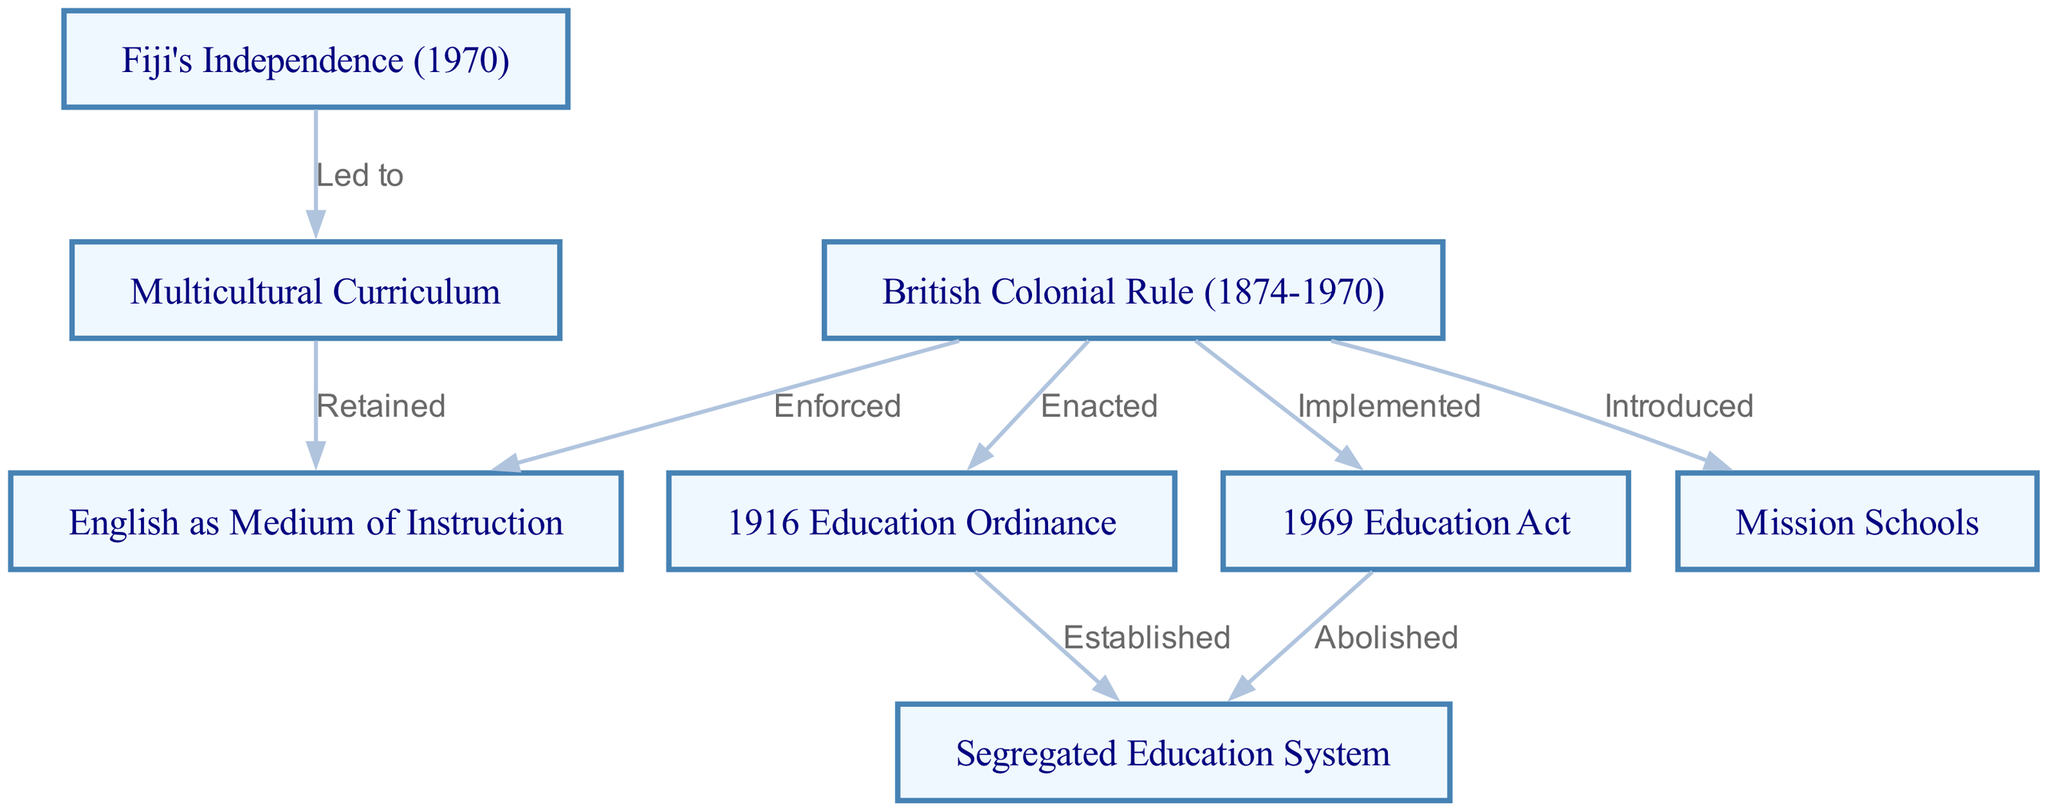What is the starting point of the directed graph? The directed graph starts from the node labeled "British Colonial Rule (1874-1970)", which is depicted at the top and signifies the beginning of the information flow in the diagram.
Answer: British Colonial Rule (1874-1970) How many nodes are present in the diagram? By counting the unique labels listed in the nodes section, we find that there are a total of 8 distinct nodes representing various aspects of the colonial influences on the Fijian education system.
Answer: 8 Which ordinance established a segregated education system in Fiji? The "1916 Education Ordinance" is shown in the diagram as the node that directly leads to the establishment of the segregated education system, indicated by the edge relationship in the graph.
Answer: 1916 Education Ordinance What legislation abolished the segregated education system? According to the graph, the "1969 Education Act" directly leads to the abolition of the "Segregated Education System," denoting a significant policy change.
Answer: 1969 Education Act What curriculum was initiated after Fiji's independence? The diagram illustrates that following Fiji's independence in 1970, a "Multicultural Curriculum" was led to, indicating a shift towards inclusivity in education in Fiji.
Answer: Multicultural Curriculum What relationship does the "British Colonial Rule" have with "English as Medium of Instruction"? The directed edge from "British Colonial Rule" to "English as Medium of Instruction" shows that during British rule, the use of English as the primary language in education was enforced.
Answer: Enforced How did the 1969 Education Act relate to the previous educational policies? The diagram shows that the "1969 Education Act" implemented changes that abolished the existing "Segregated Education System," representing a significant reform compared to prior policies.
Answer: Abolished Which two nodes are connected through a "Led to" relationship? In the diagram, the edge labeled "Led to" connects the node for "Fiji's Independence (1970)" with the node for "Multicultural Curriculum," indicating a causal influence.
Answer: Fiji's Independence (1970) and Multicultural Curriculum What has been retained after the introduction of the Multicultural Curriculum? The diagram indicates that even after the establishment of the "Multicultural Curriculum," the "English as Medium of Instruction" has been retained, suggesting continuity in language policy.
Answer: English as Medium of Instruction 